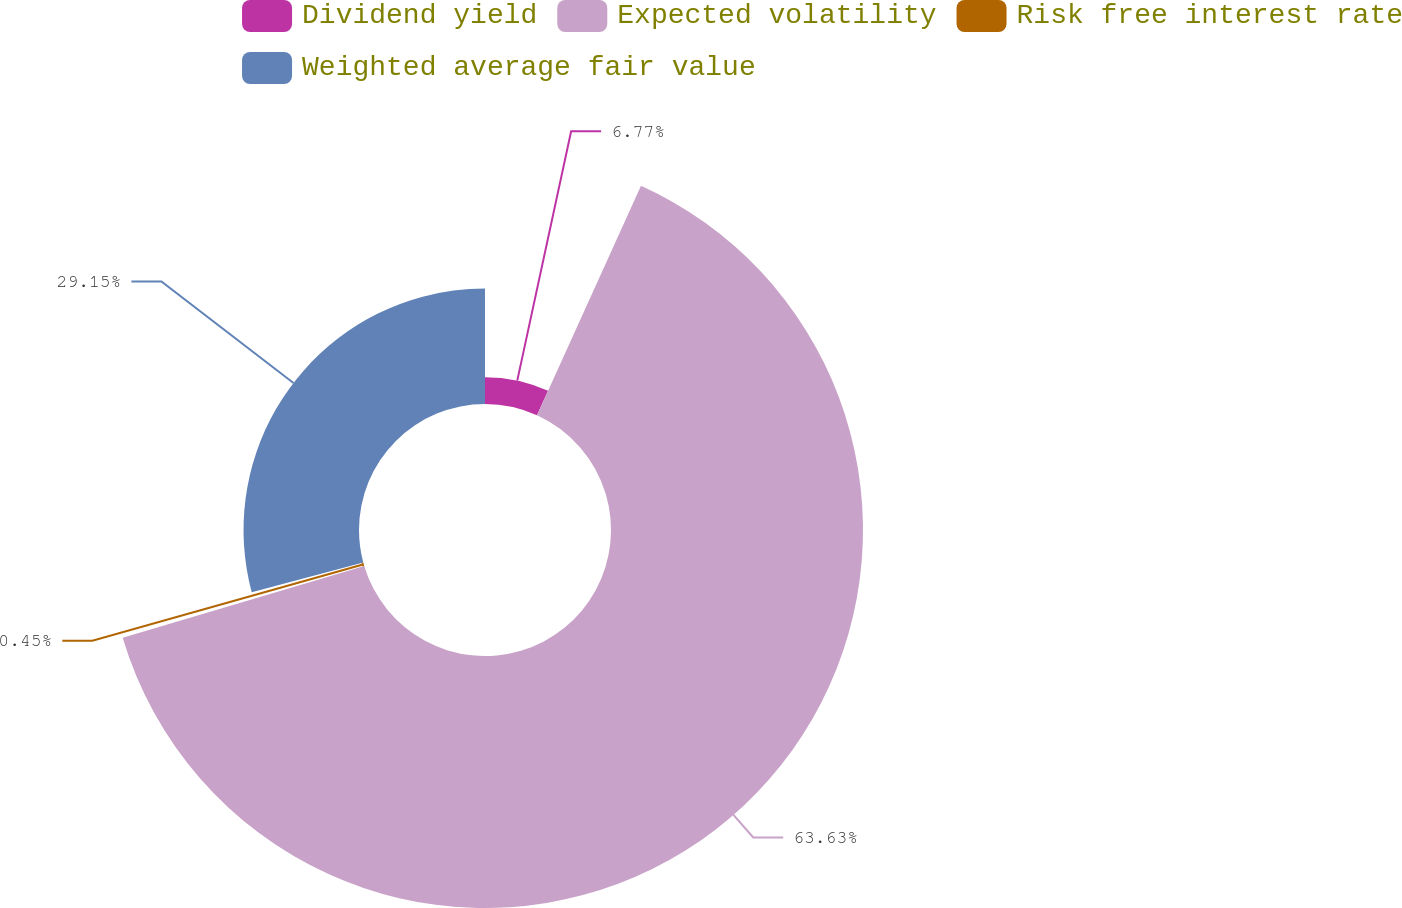<chart> <loc_0><loc_0><loc_500><loc_500><pie_chart><fcel>Dividend yield<fcel>Expected volatility<fcel>Risk free interest rate<fcel>Weighted average fair value<nl><fcel>6.77%<fcel>63.62%<fcel>0.45%<fcel>29.15%<nl></chart> 